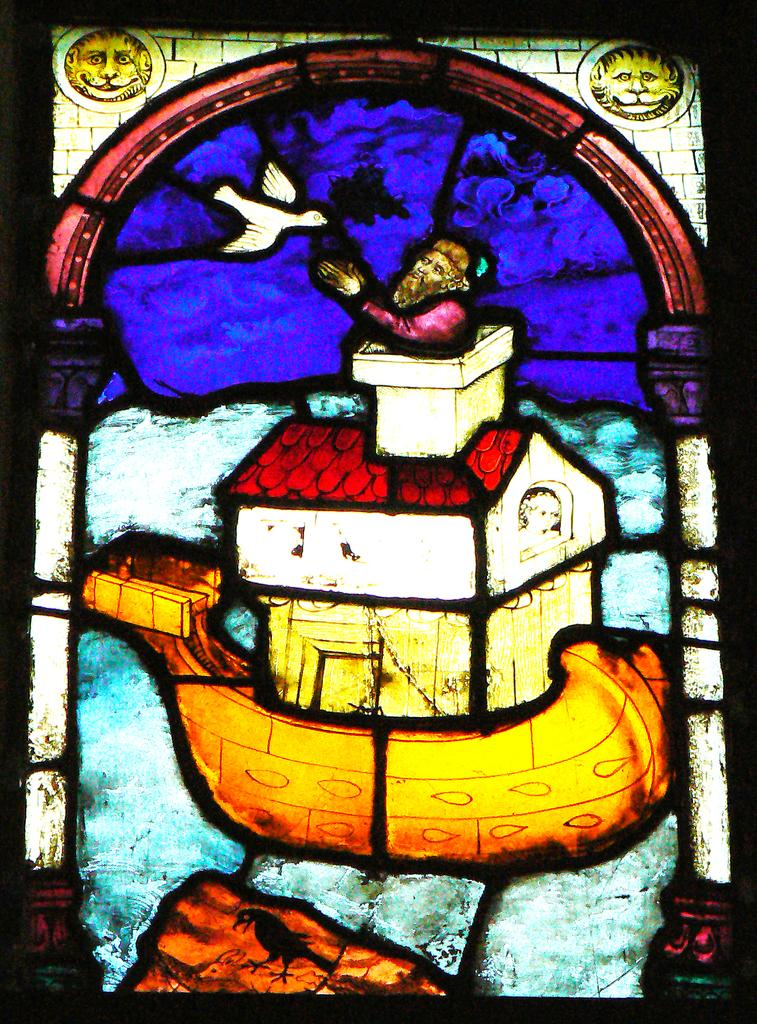What type of artwork is shown in the image? The image consists of a painting. What is the subject matter of the painting? The painting appears to depict a glass of a window. What type of train can be seen passing by the window in the painting? There is no train present in the painting; it depicts a glass of a window. Can you tell me when the birth of the artist occurred based on the painting? The painting does not provide any information about the artist's birth, as it only depicts a glass of a window. 